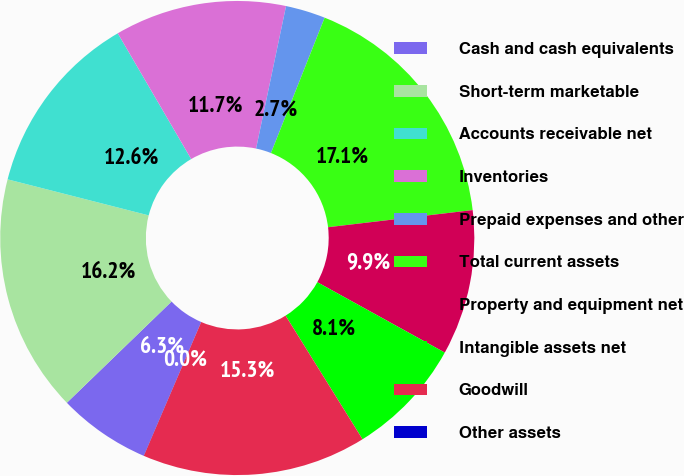Convert chart to OTSL. <chart><loc_0><loc_0><loc_500><loc_500><pie_chart><fcel>Cash and cash equivalents<fcel>Short-term marketable<fcel>Accounts receivable net<fcel>Inventories<fcel>Prepaid expenses and other<fcel>Total current assets<fcel>Property and equipment net<fcel>Intangible assets net<fcel>Goodwill<fcel>Other assets<nl><fcel>6.31%<fcel>16.21%<fcel>12.61%<fcel>11.71%<fcel>2.71%<fcel>17.11%<fcel>9.91%<fcel>8.11%<fcel>15.31%<fcel>0.01%<nl></chart> 